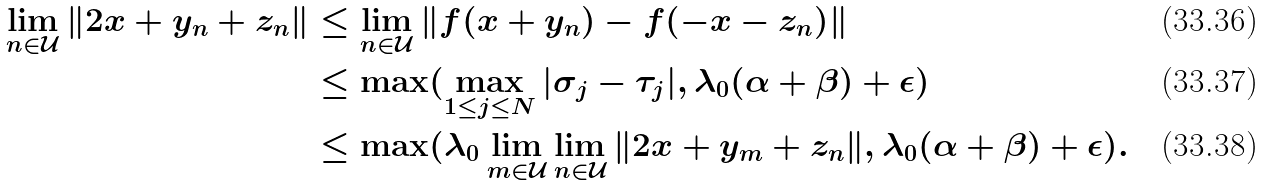<formula> <loc_0><loc_0><loc_500><loc_500>\lim _ { n \in \mathcal { U } } \| 2 x + y _ { n } + z _ { n } \| & \leq \lim _ { n \in \mathcal { U } } \| f ( x + y _ { n } ) - f ( - x - z _ { n } ) \| \\ & \leq \max ( \max _ { 1 \leq j \leq N } | \sigma _ { j } - \tau _ { j } | , \lambda _ { 0 } ( \alpha + \beta ) + \epsilon ) \\ & \leq \max ( \lambda _ { 0 } \lim _ { m \in \mathcal { U } } \lim _ { n \in \mathcal { U } } \| 2 x + y _ { m } + z _ { n } \| , \lambda _ { 0 } ( \alpha + \beta ) + \epsilon ) .</formula> 